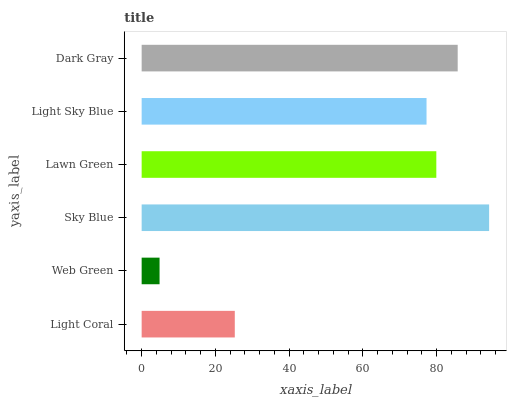Is Web Green the minimum?
Answer yes or no. Yes. Is Sky Blue the maximum?
Answer yes or no. Yes. Is Sky Blue the minimum?
Answer yes or no. No. Is Web Green the maximum?
Answer yes or no. No. Is Sky Blue greater than Web Green?
Answer yes or no. Yes. Is Web Green less than Sky Blue?
Answer yes or no. Yes. Is Web Green greater than Sky Blue?
Answer yes or no. No. Is Sky Blue less than Web Green?
Answer yes or no. No. Is Lawn Green the high median?
Answer yes or no. Yes. Is Light Sky Blue the low median?
Answer yes or no. Yes. Is Light Sky Blue the high median?
Answer yes or no. No. Is Dark Gray the low median?
Answer yes or no. No. 